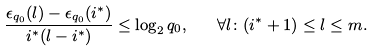Convert formula to latex. <formula><loc_0><loc_0><loc_500><loc_500>\frac { \epsilon _ { q _ { 0 } } ( l ) - \epsilon _ { q _ { 0 } } ( i ^ { * } ) } { i ^ { * } ( l - i ^ { * } ) } \leq \log _ { 2 } { q _ { 0 } } , \quad \forall l \colon ( i ^ { * } + 1 ) \leq l \leq m .</formula> 